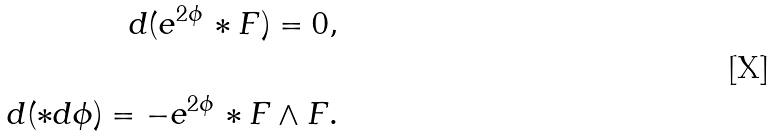Convert formula to latex. <formula><loc_0><loc_0><loc_500><loc_500>d ( e ^ { 2 \phi } \, \ast F ) = 0 , \\ \\ d ( \ast d \phi ) = - e ^ { 2 \phi } \, \ast F \wedge F .</formula> 